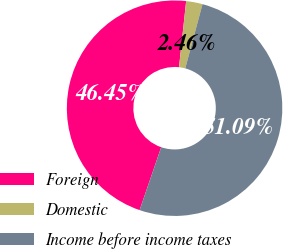Convert chart. <chart><loc_0><loc_0><loc_500><loc_500><pie_chart><fcel>Foreign<fcel>Domestic<fcel>Income before income taxes<nl><fcel>46.45%<fcel>2.46%<fcel>51.09%<nl></chart> 